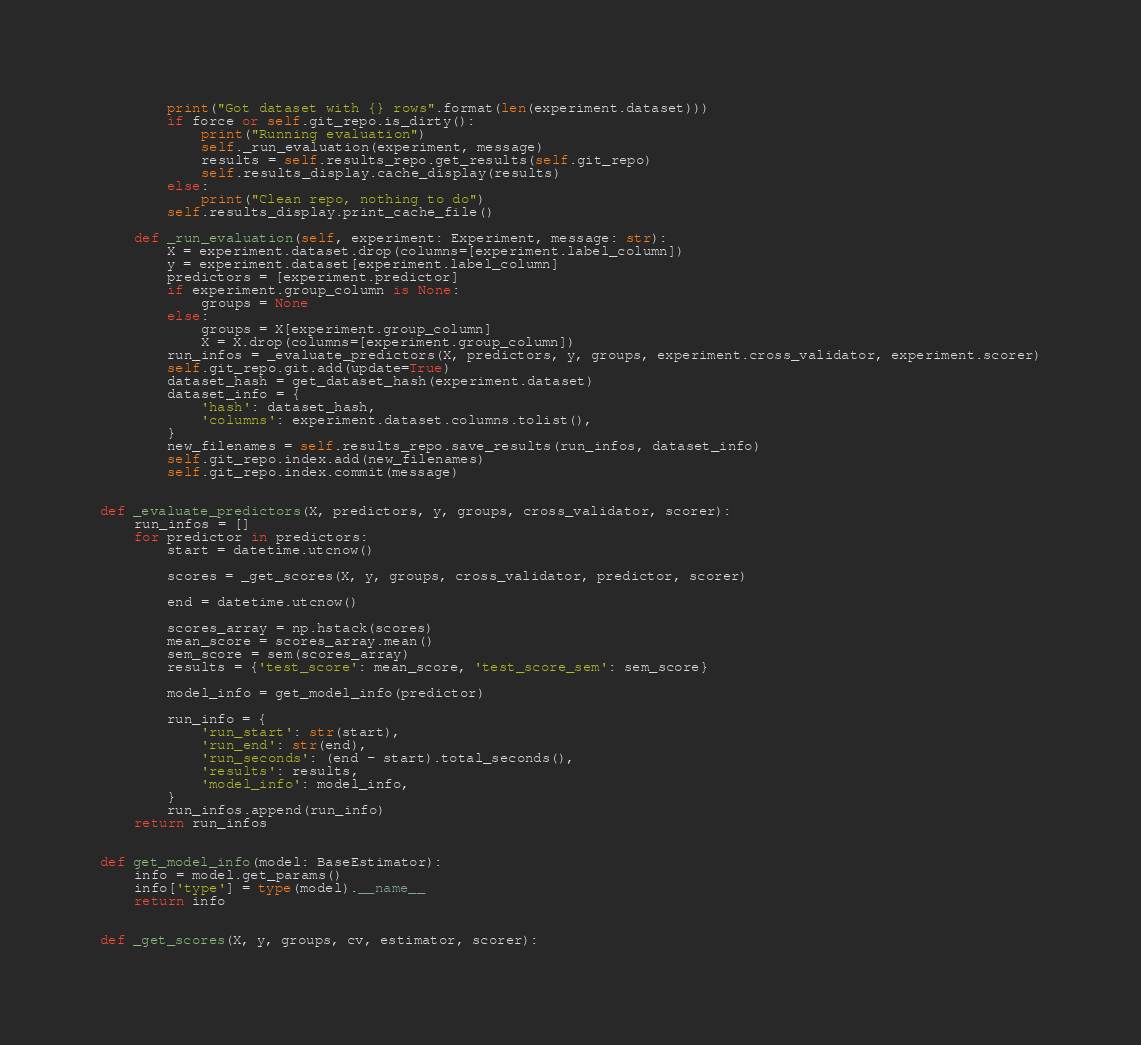<code> <loc_0><loc_0><loc_500><loc_500><_Python_>        print("Got dataset with {} rows".format(len(experiment.dataset)))
        if force or self.git_repo.is_dirty():
            print("Running evaluation")
            self._run_evaluation(experiment, message)
            results = self.results_repo.get_results(self.git_repo)
            self.results_display.cache_display(results)
        else:
            print("Clean repo, nothing to do")
        self.results_display.print_cache_file()

    def _run_evaluation(self, experiment: Experiment, message: str):
        X = experiment.dataset.drop(columns=[experiment.label_column])
        y = experiment.dataset[experiment.label_column]
        predictors = [experiment.predictor]
        if experiment.group_column is None:
            groups = None
        else:
            groups = X[experiment.group_column]
            X = X.drop(columns=[experiment.group_column])
        run_infos = _evaluate_predictors(X, predictors, y, groups, experiment.cross_validator, experiment.scorer)
        self.git_repo.git.add(update=True)
        dataset_hash = get_dataset_hash(experiment.dataset)
        dataset_info = {
            'hash': dataset_hash,
            'columns': experiment.dataset.columns.tolist(),
        }
        new_filenames = self.results_repo.save_results(run_infos, dataset_info)
        self.git_repo.index.add(new_filenames)
        self.git_repo.index.commit(message)


def _evaluate_predictors(X, predictors, y, groups, cross_validator, scorer):
    run_infos = []
    for predictor in predictors:
        start = datetime.utcnow()

        scores = _get_scores(X, y, groups, cross_validator, predictor, scorer)

        end = datetime.utcnow()

        scores_array = np.hstack(scores)
        mean_score = scores_array.mean()
        sem_score = sem(scores_array)
        results = {'test_score': mean_score, 'test_score_sem': sem_score}

        model_info = get_model_info(predictor)

        run_info = {
            'run_start': str(start),
            'run_end': str(end),
            'run_seconds': (end - start).total_seconds(),
            'results': results,
            'model_info': model_info,
        }
        run_infos.append(run_info)
    return run_infos


def get_model_info(model: BaseEstimator):
    info = model.get_params()
    info['type'] = type(model).__name__
    return info


def _get_scores(X, y, groups, cv, estimator, scorer):</code> 